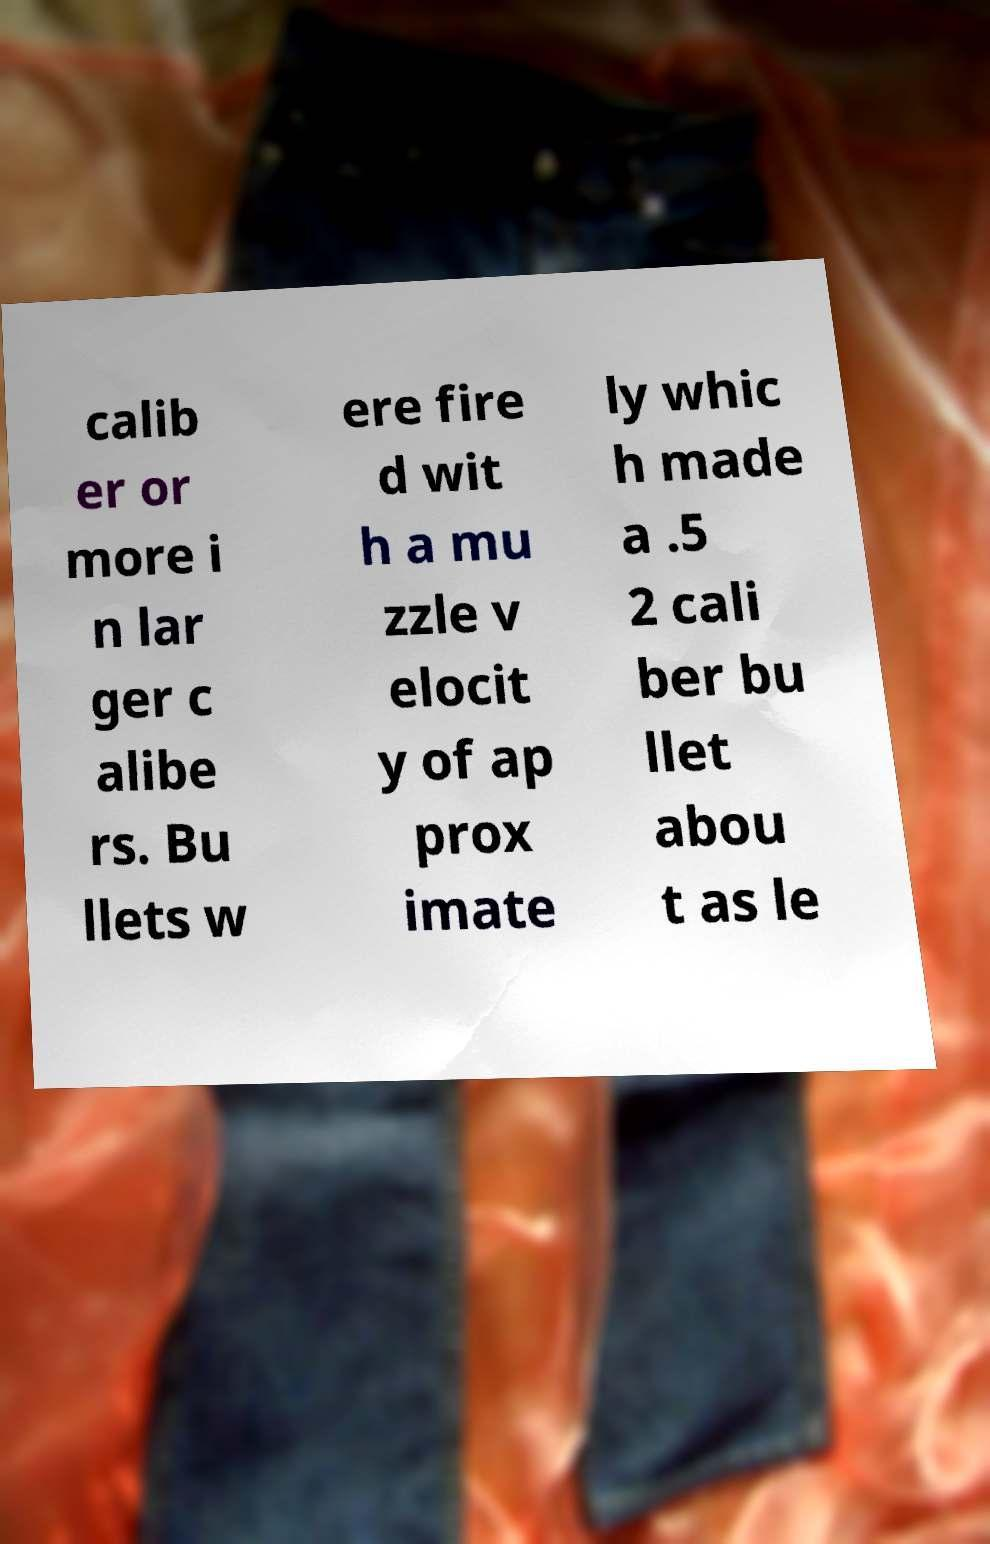Can you read and provide the text displayed in the image?This photo seems to have some interesting text. Can you extract and type it out for me? calib er or more i n lar ger c alibe rs. Bu llets w ere fire d wit h a mu zzle v elocit y of ap prox imate ly whic h made a .5 2 cali ber bu llet abou t as le 